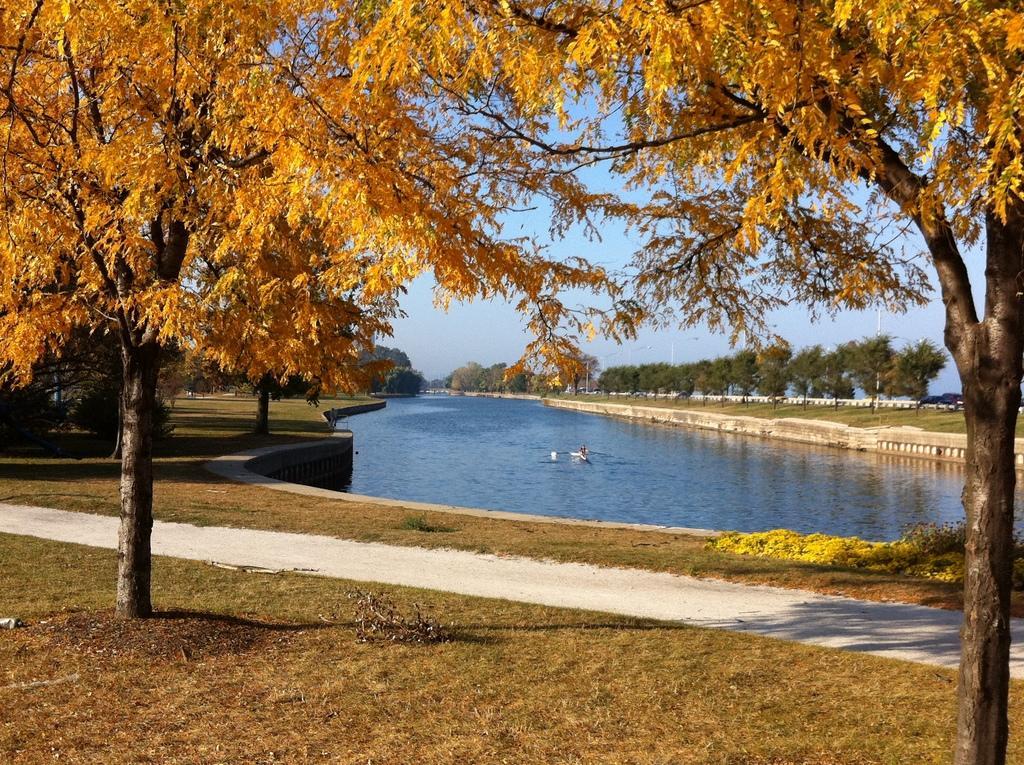Could you give a brief overview of what you see in this image? In this image we can see a lake. Around the lake trees and grasslands are there. Background of the image sky is present. 